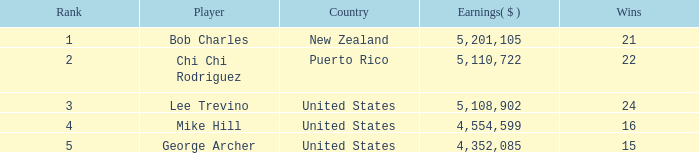Cumulatively, how much did the us player george archer make with fewer than 24 wins and a ranking exceeding 5? 0.0. 